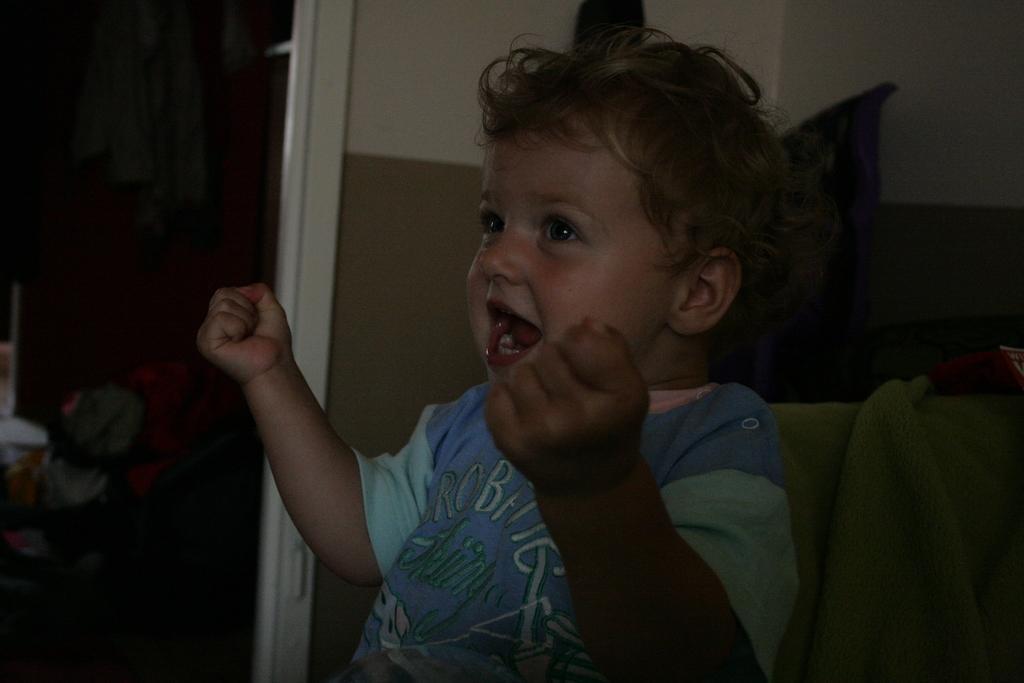Could you give a brief overview of what you see in this image? In this image I see a child who is wearing blue dress and I see something is written on the dress and it is dark in the background and I see the wall which is of white and brown in color. 